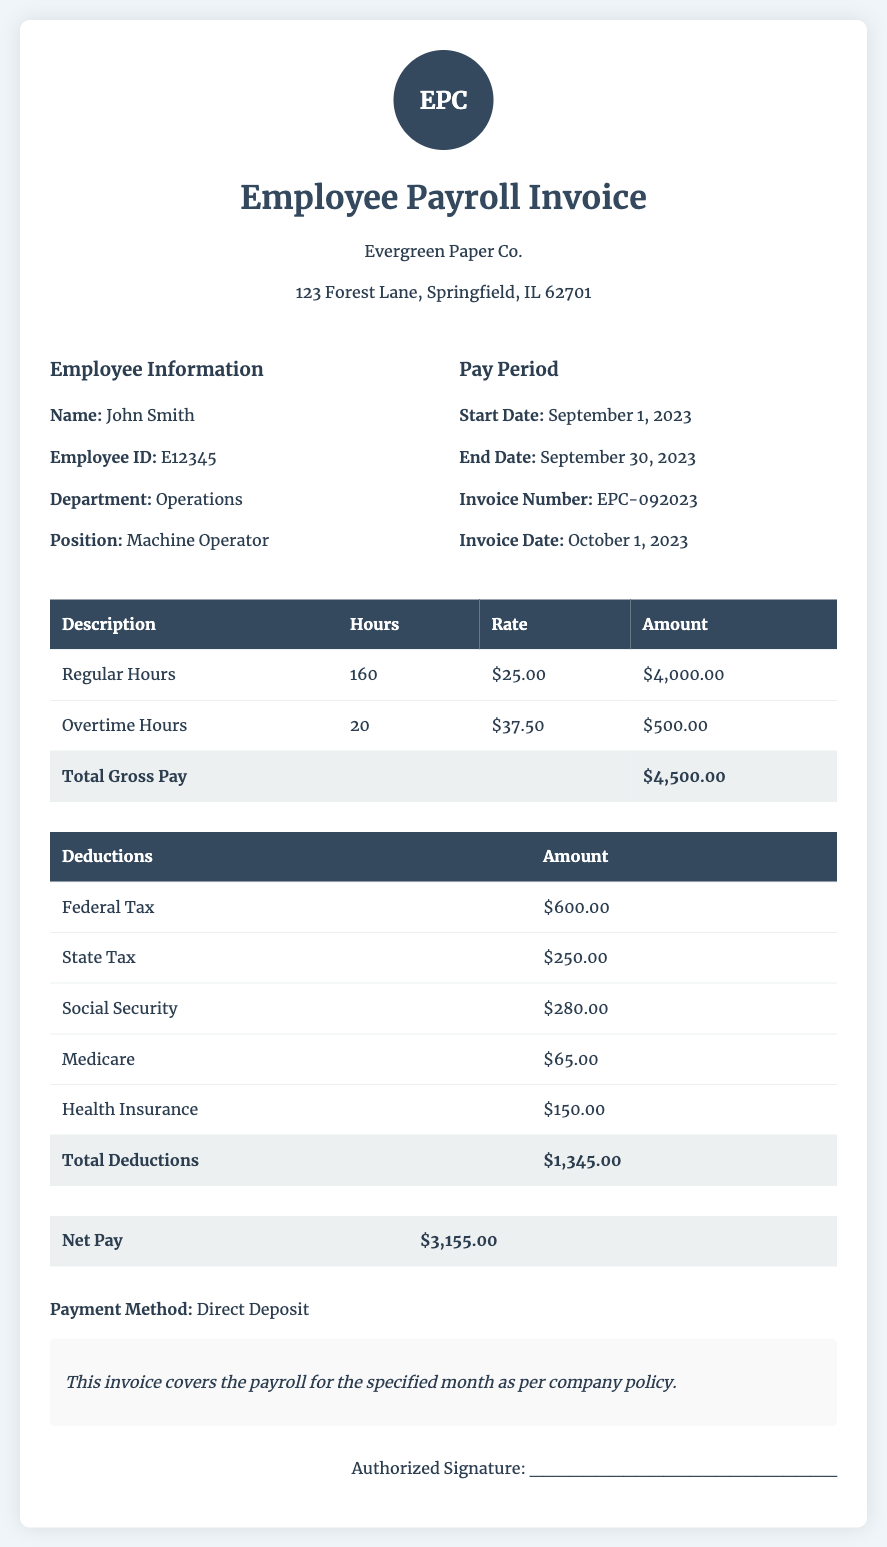What is the employee's name? The employee's name is listed in the document as John Smith.
Answer: John Smith What is the total gross pay? The total gross pay is summarized in the document and is stated as $4,500.00.
Answer: $4,500.00 What is the start date of the pay period? The start date of the pay period is provided in the document as September 1, 2023.
Answer: September 1, 2023 How many overtime hours were worked? The document specifies that 20 overtime hours were worked during this period.
Answer: 20 What is the total amount of deductions? The total amount of deductions is calculated in the document, amounting to $1,345.00.
Answer: $1,345.00 What is the net pay? The net pay is clearly stated in the document at $3,155.00.
Answer: $3,155.00 What is the employee's position? The employee's position is provided as Machine Operator in the document.
Answer: Machine Operator What method of payment is used? The document specifies that the payment method is Direct Deposit.
Answer: Direct Deposit What was the invoice date? The invoice date is mentioned in the document as October 1, 2023.
Answer: October 1, 2023 